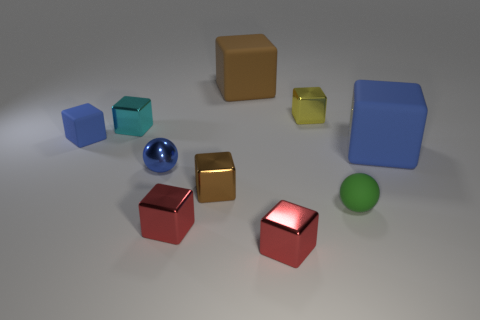Subtract all blue blocks. How many blocks are left? 6 Subtract all blue cubes. How many cubes are left? 6 Subtract all purple cubes. Subtract all brown balls. How many cubes are left? 8 Subtract all spheres. How many objects are left? 8 Subtract all big purple rubber cylinders. Subtract all green matte balls. How many objects are left? 9 Add 1 tiny red shiny blocks. How many tiny red shiny blocks are left? 3 Add 5 large rubber things. How many large rubber things exist? 7 Subtract 2 red blocks. How many objects are left? 8 